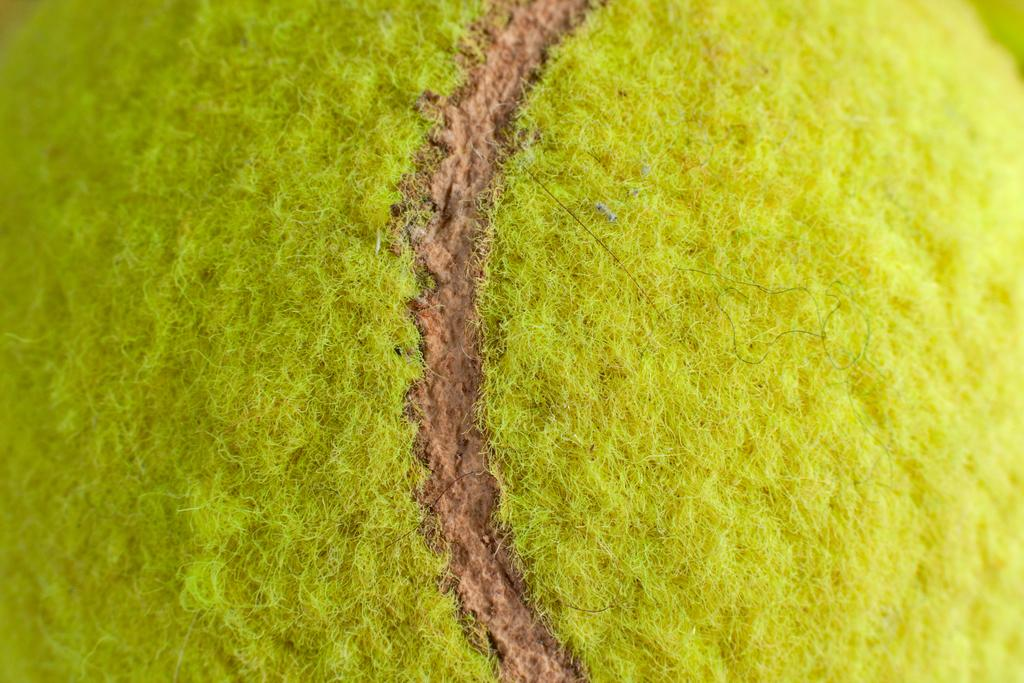What object is present in the image? There is a tennis ball in the image. Can you tell me how many hens are talking to each other in the image? There are no hens present in the image, and therefore no such conversation can be observed. 